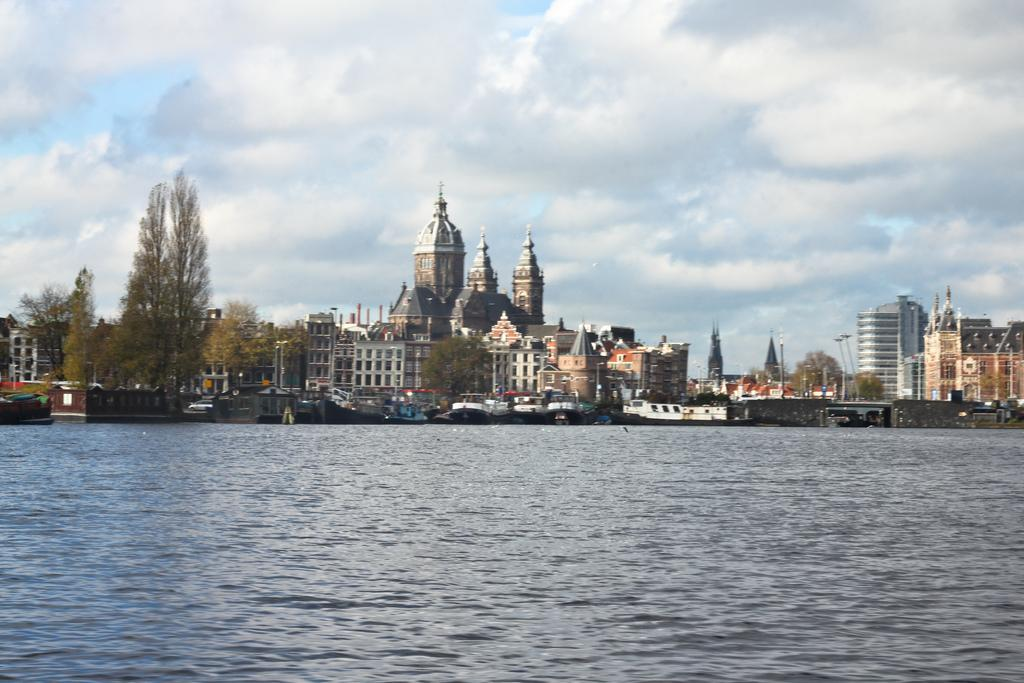What type of structures can be seen in the image? There are buildings in the image. What other natural elements are present in the image? There are trees in the image. What can be seen in the water in the image? There are boats in the water in the image. How would you describe the sky in the image? The sky is blue and cloudy in the image. Where is the sign that indicates the location of the jewel in the image? There is no sign or jewel present in the image. What type of boot is being worn by the person in the image? There are no people or boots visible in the image. 